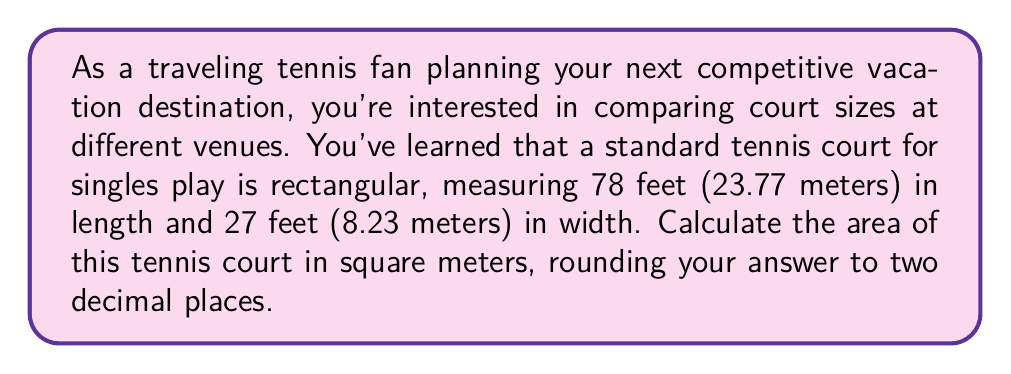Solve this math problem. To solve this problem, we'll follow these steps:

1. Identify the formula for the area of a rectangle:
   $$ A = l \times w $$
   where $A$ is the area, $l$ is the length, and $w$ is the width.

2. Convert the given dimensions from feet to meters:
   Length: 78 feet = 23.77 meters
   Width: 27 feet = 8.23 meters

3. Apply the formula using the dimensions in meters:
   $$ A = 23.77 \text{ m} \times 8.23 \text{ m} $$

4. Perform the multiplication:
   $$ A = 195.6271 \text{ m}^2 $$

5. Round the result to two decimal places:
   $$ A \approx 195.63 \text{ m}^2 $$

[asy]
unitsize(0.1cm);
draw((0,0)--(23.77,0)--(23.77,8.23)--(0,8.23)--cycle);
label("23.77 m", (11.885,0), S);
label("8.23 m", (0,4.115), W);
label("Tennis Court", (11.885,4.115), N);
[/asy]
Answer: $195.63 \text{ m}^2$ 